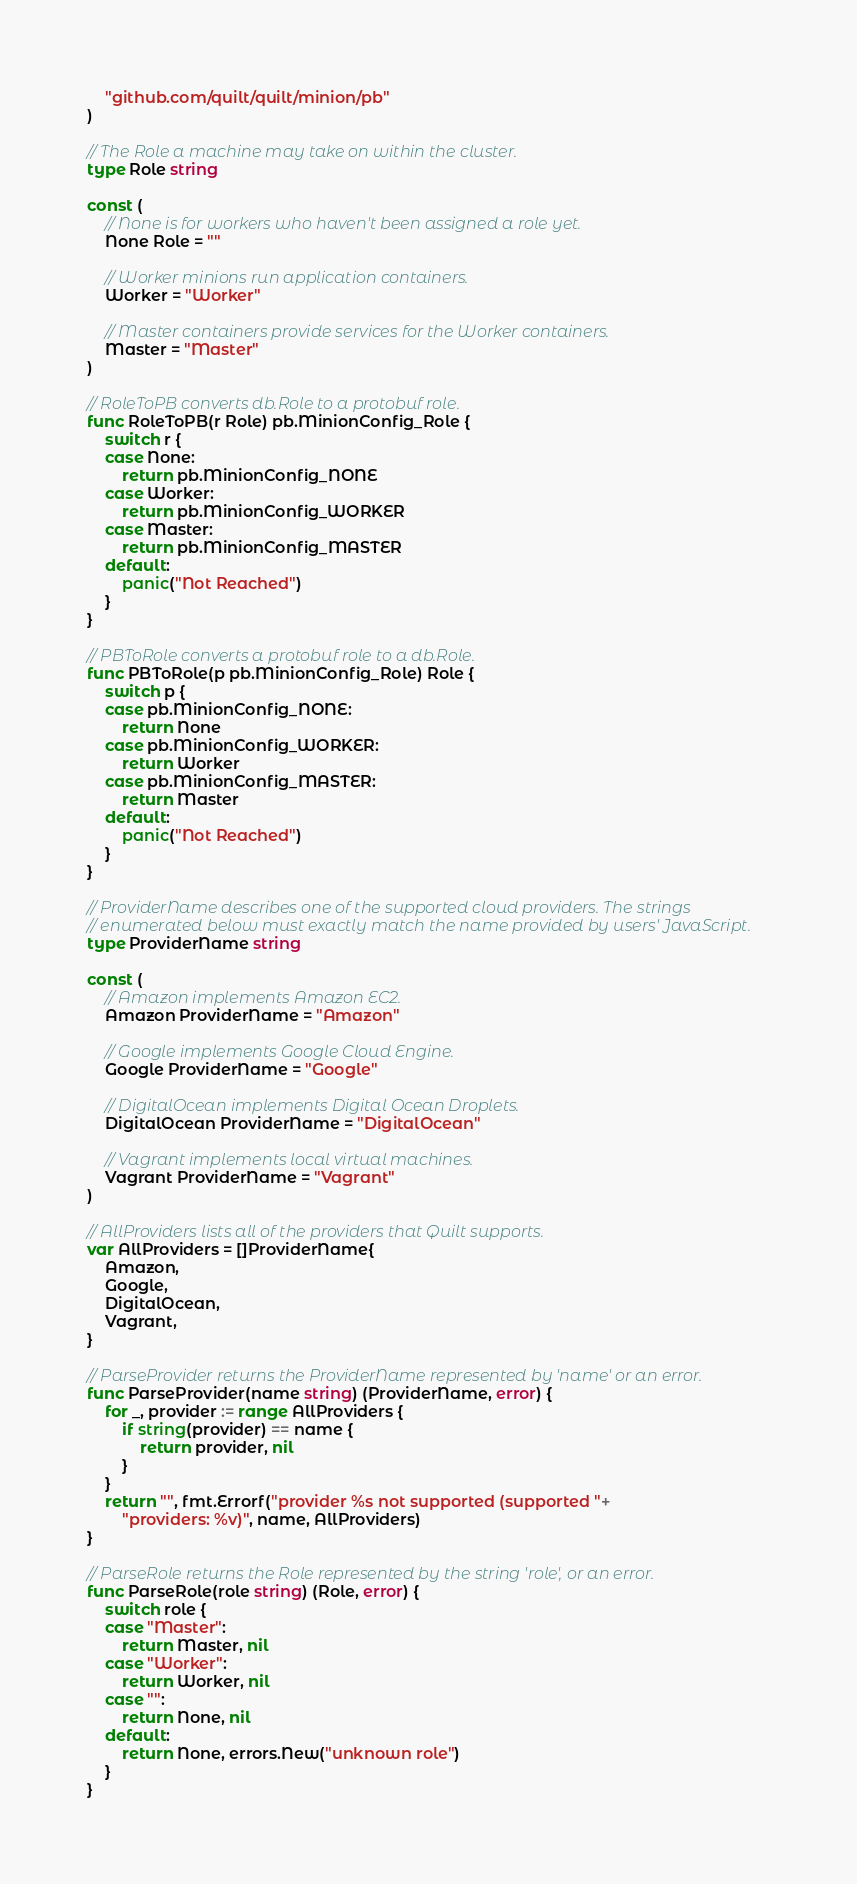<code> <loc_0><loc_0><loc_500><loc_500><_Go_>	"github.com/quilt/quilt/minion/pb"
)

// The Role a machine may take on within the cluster.
type Role string

const (
	// None is for workers who haven't been assigned a role yet.
	None Role = ""

	// Worker minions run application containers.
	Worker = "Worker"

	// Master containers provide services for the Worker containers.
	Master = "Master"
)

// RoleToPB converts db.Role to a protobuf role.
func RoleToPB(r Role) pb.MinionConfig_Role {
	switch r {
	case None:
		return pb.MinionConfig_NONE
	case Worker:
		return pb.MinionConfig_WORKER
	case Master:
		return pb.MinionConfig_MASTER
	default:
		panic("Not Reached")
	}
}

// PBToRole converts a protobuf role to a db.Role.
func PBToRole(p pb.MinionConfig_Role) Role {
	switch p {
	case pb.MinionConfig_NONE:
		return None
	case pb.MinionConfig_WORKER:
		return Worker
	case pb.MinionConfig_MASTER:
		return Master
	default:
		panic("Not Reached")
	}
}

// ProviderName describes one of the supported cloud providers. The strings
// enumerated below must exactly match the name provided by users' JavaScript.
type ProviderName string

const (
	// Amazon implements Amazon EC2.
	Amazon ProviderName = "Amazon"

	// Google implements Google Cloud Engine.
	Google ProviderName = "Google"

	// DigitalOcean implements Digital Ocean Droplets.
	DigitalOcean ProviderName = "DigitalOcean"

	// Vagrant implements local virtual machines.
	Vagrant ProviderName = "Vagrant"
)

// AllProviders lists all of the providers that Quilt supports.
var AllProviders = []ProviderName{
	Amazon,
	Google,
	DigitalOcean,
	Vagrant,
}

// ParseProvider returns the ProviderName represented by 'name' or an error.
func ParseProvider(name string) (ProviderName, error) {
	for _, provider := range AllProviders {
		if string(provider) == name {
			return provider, nil
		}
	}
	return "", fmt.Errorf("provider %s not supported (supported "+
		"providers: %v)", name, AllProviders)
}

// ParseRole returns the Role represented by the string 'role', or an error.
func ParseRole(role string) (Role, error) {
	switch role {
	case "Master":
		return Master, nil
	case "Worker":
		return Worker, nil
	case "":
		return None, nil
	default:
		return None, errors.New("unknown role")
	}
}
</code> 